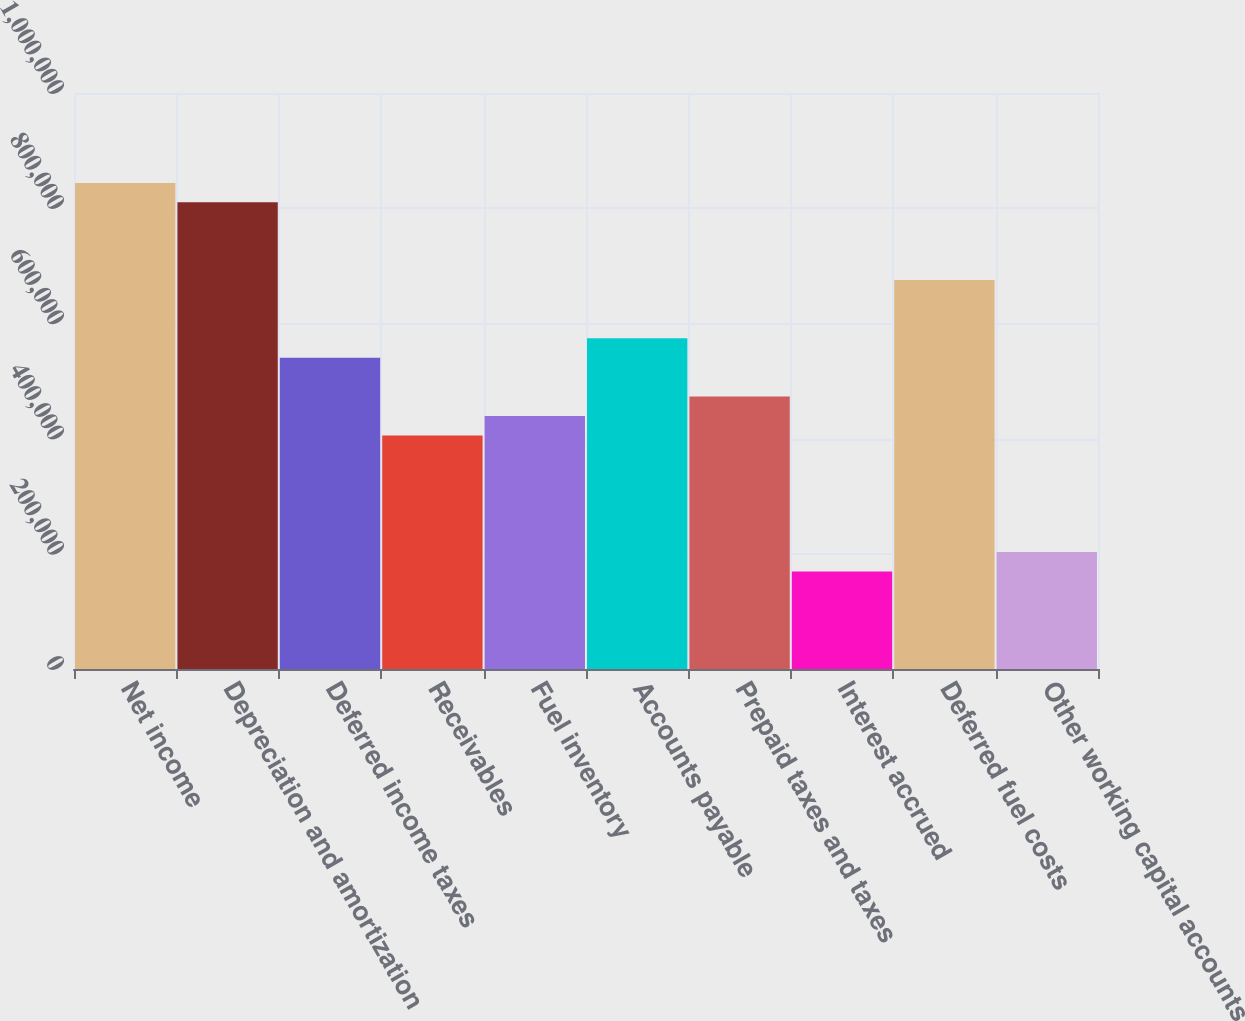Convert chart to OTSL. <chart><loc_0><loc_0><loc_500><loc_500><bar_chart><fcel>Net income<fcel>Depreciation and amortization<fcel>Deferred income taxes<fcel>Receivables<fcel>Fuel inventory<fcel>Accounts payable<fcel>Prepaid taxes and taxes<fcel>Interest accrued<fcel>Deferred fuel costs<fcel>Other working capital accounts<nl><fcel>843886<fcel>810158<fcel>540332<fcel>405419<fcel>439148<fcel>574060<fcel>472876<fcel>169322<fcel>675245<fcel>203050<nl></chart> 